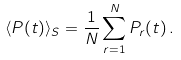Convert formula to latex. <formula><loc_0><loc_0><loc_500><loc_500>\langle P ( t ) \rangle _ { S } = \frac { 1 } { N } \sum _ { r = 1 } ^ { N } P _ { r } ( t ) \, .</formula> 